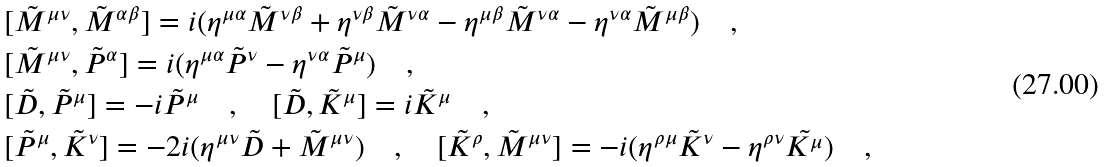<formula> <loc_0><loc_0><loc_500><loc_500>& [ \tilde { M } ^ { \mu \nu } , \tilde { M } ^ { \alpha \beta } ] = i ( \eta ^ { \mu \alpha } \tilde { M } ^ { \nu \beta } + \eta ^ { \nu \beta } \tilde { M } ^ { \nu \alpha } - \eta ^ { \mu \beta } \tilde { M } ^ { \nu \alpha } - \eta ^ { \nu \alpha } \tilde { M } ^ { \mu \beta } ) \quad , \\ & [ \tilde { M } ^ { \mu \nu } , \tilde { P } ^ { \alpha } ] = i ( \eta ^ { \mu \alpha } \tilde { P } ^ { \nu } - \eta ^ { \nu \alpha } \tilde { P } ^ { \mu } ) \quad , \\ & [ \tilde { D } , \tilde { P } ^ { \mu } ] = - i \tilde { P } ^ { \mu } \quad , \quad [ \tilde { D } , \tilde { K } ^ { \mu } ] = i \tilde { K } ^ { \mu } \quad , \\ & [ \tilde { P } ^ { \mu } , \tilde { K } ^ { \nu } ] = - 2 i ( \eta ^ { \mu \nu } \tilde { D } + \tilde { M } ^ { \mu \nu } ) \quad , \quad [ \tilde { K } ^ { \rho } , \tilde { M } ^ { \mu \nu } ] = - i ( \eta ^ { \rho \mu } \tilde { K } ^ { \nu } - \eta ^ { \rho \nu } \tilde { K ^ { \mu } } ) \quad ,</formula> 